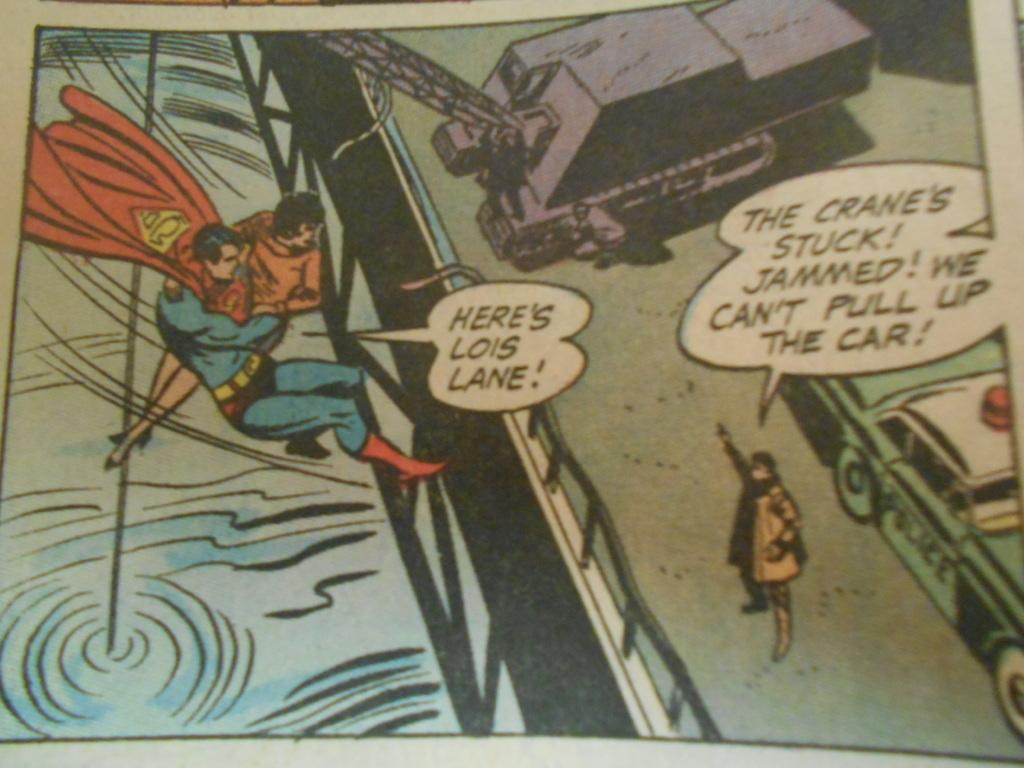<image>
Describe the image concisely. A panel of a comic book shows Superman saying "Here's Lois Lane!" 